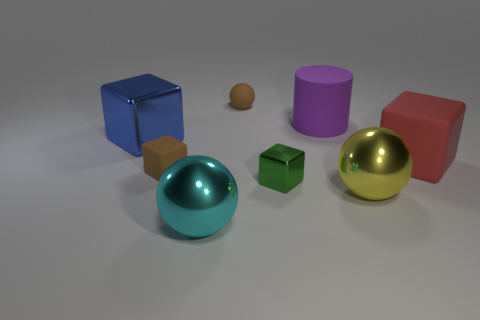Are there an equal number of brown objects that are left of the big cyan shiny ball and brown objects?
Ensure brevity in your answer.  No. There is a ball that is behind the large red thing that is right of the big blue shiny object; how many cubes are right of it?
Provide a succinct answer. 2. The metallic cube that is on the left side of the green object is what color?
Your answer should be compact. Blue. There is a object that is to the right of the purple cylinder and behind the big yellow shiny thing; what material is it made of?
Give a very brief answer. Rubber. What number of blue cubes are to the left of the metallic cube that is to the left of the brown matte sphere?
Offer a very short reply. 0. The yellow metal thing has what shape?
Your response must be concise. Sphere. The yellow thing that is made of the same material as the blue thing is what shape?
Make the answer very short. Sphere. There is a small brown matte object on the left side of the large cyan metallic thing; does it have the same shape as the blue thing?
Offer a very short reply. Yes. There is a small brown object behind the red cube; what is its shape?
Offer a very short reply. Sphere. The matte thing that is the same color as the small matte cube is what shape?
Offer a very short reply. Sphere. 